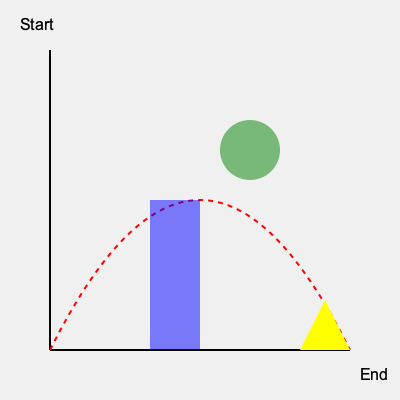In this classic platformer-style game, a projectile is launched from the left side of the screen and follows the red dotted path. Given the obstacles in its way (blue rectangle, green circle, and yellow triangle), at which point is the projectile most likely to be deflected from its original trajectory? To determine where the projectile is most likely to be deflected, we need to analyze its path and the obstacles:

1. The projectile follows a parabolic trajectory, as indicated by the red dotted line. This is typical for objects affected by gravity in games.

2. There are three obstacles in the path:
   a. Blue rectangle: Located in the lower middle of the screen
   b. Green circle: Positioned in the upper middle of the screen
   c. Yellow triangle: Placed at the bottom right of the screen

3. Analyzing the interaction with each obstacle:
   a. Blue rectangle: The projectile's path passes above this obstacle, so there's no collision.
   b. Green circle: The projectile's trajectory intersects with this obstacle at its peak. This is the most likely point of deflection because:
      - It's the first obstacle in the path that the projectile encounters.
      - The projectile is at its slowest speed at the peak of its arc, making it more susceptible to deflection.
      - The circular shape of the obstacle can cause unpredictable bounces or deflections.
   c. Yellow triangle: While the projectile's path does intersect with this obstacle, it occurs at the end of the trajectory when the projectile has gained significant downward velocity. This makes it less likely to cause a significant deflection compared to the green circle.

4. In many games, objects like the green circle are often designed as "bounce pads" or deflectors, further supporting this as the most likely point of deflection.

Therefore, the green circle is the most probable point where the projectile will be deflected from its original trajectory.
Answer: Green circle 